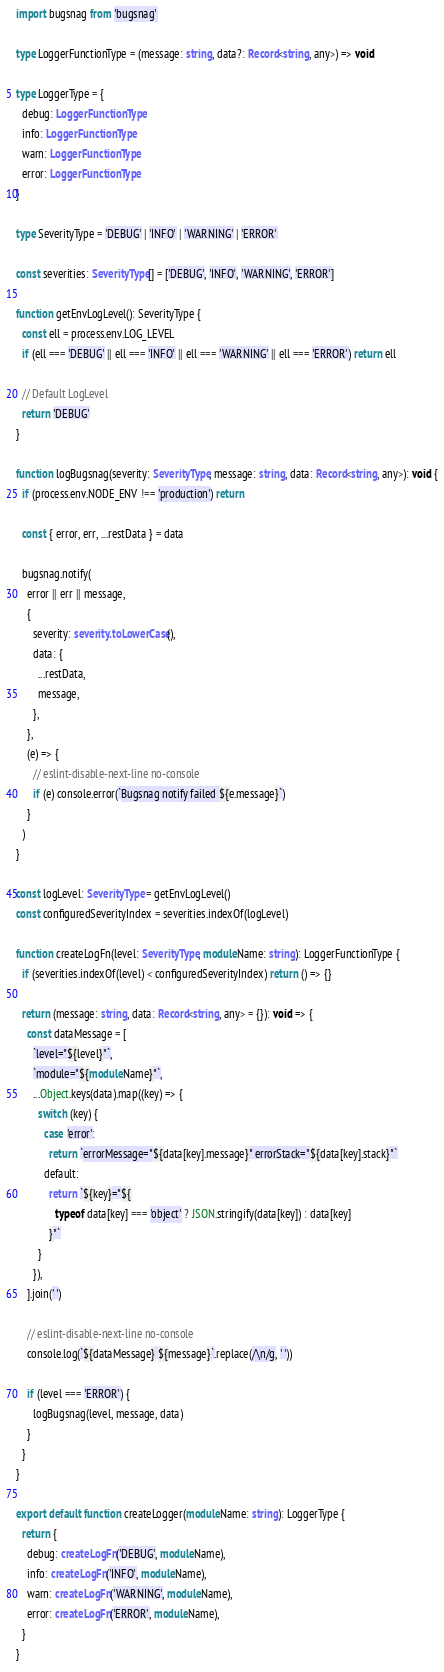<code> <loc_0><loc_0><loc_500><loc_500><_TypeScript_>import bugsnag from 'bugsnag'

type LoggerFunctionType = (message: string, data?: Record<string, any>) => void

type LoggerType = {
  debug: LoggerFunctionType
  info: LoggerFunctionType
  warn: LoggerFunctionType
  error: LoggerFunctionType
}

type SeverityType = 'DEBUG' | 'INFO' | 'WARNING' | 'ERROR'

const severities: SeverityType[] = ['DEBUG', 'INFO', 'WARNING', 'ERROR']

function getEnvLogLevel(): SeverityType {
  const ell = process.env.LOG_LEVEL
  if (ell === 'DEBUG' || ell === 'INFO' || ell === 'WARNING' || ell === 'ERROR') return ell

  // Default LogLevel
  return 'DEBUG'
}

function logBugsnag(severity: SeverityType, message: string, data: Record<string, any>): void {
  if (process.env.NODE_ENV !== 'production') return

  const { error, err, ...restData } = data

  bugsnag.notify(
    error || err || message,
    {
      severity: severity.toLowerCase(),
      data: {
        ...restData,
        message,
      },
    },
    (e) => {
      // eslint-disable-next-line no-console
      if (e) console.error(`Bugsnag notify failed ${e.message}`)
    }
  )
}

const logLevel: SeverityType = getEnvLogLevel()
const configuredSeverityIndex = severities.indexOf(logLevel)

function createLogFn(level: SeverityType, moduleName: string): LoggerFunctionType {
  if (severities.indexOf(level) < configuredSeverityIndex) return () => {}

  return (message: string, data: Record<string, any> = {}): void => {
    const dataMessage = [
      `level="${level}"`,
      `module="${moduleName}"`,
      ...Object.keys(data).map((key) => {
        switch (key) {
          case 'error':
            return `errorMessage="${data[key].message}" errorStack="${data[key].stack}"`
          default:
            return `${key}="${
              typeof data[key] === 'object' ? JSON.stringify(data[key]) : data[key]
            }"`
        }
      }),
    ].join(' ')

    // eslint-disable-next-line no-console
    console.log(`${dataMessage} ${message}`.replace(/\n/g, ' '))

    if (level === 'ERROR') {
      logBugsnag(level, message, data)
    }
  }
}

export default function createLogger(moduleName: string): LoggerType {
  return {
    debug: createLogFn('DEBUG', moduleName),
    info: createLogFn('INFO', moduleName),
    warn: createLogFn('WARNING', moduleName),
    error: createLogFn('ERROR', moduleName),
  }
}
</code> 